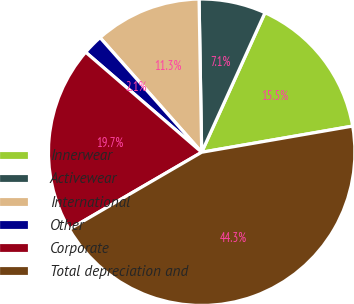Convert chart. <chart><loc_0><loc_0><loc_500><loc_500><pie_chart><fcel>Innerwear<fcel>Activewear<fcel>International<fcel>Other<fcel>Corporate<fcel>Total depreciation and<nl><fcel>15.49%<fcel>7.05%<fcel>11.27%<fcel>2.13%<fcel>19.71%<fcel>44.34%<nl></chart> 